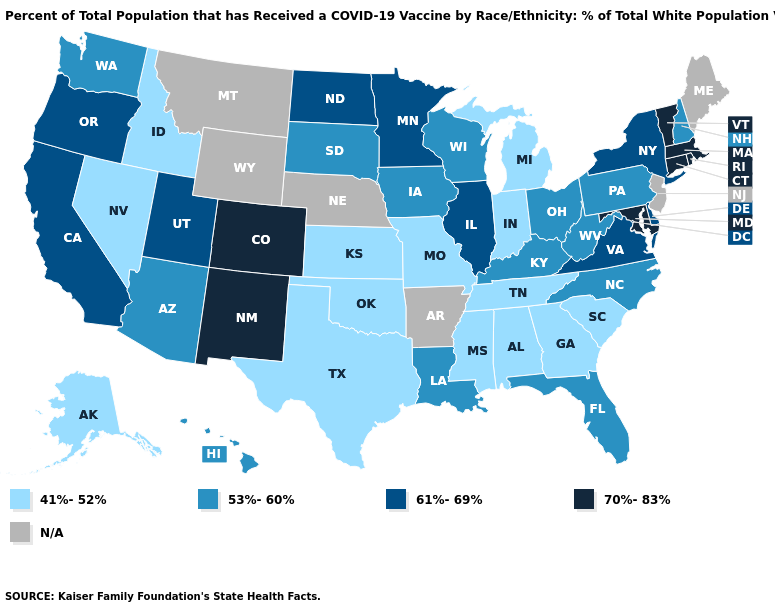Among the states that border South Dakota , does Iowa have the lowest value?
Short answer required. Yes. Does the first symbol in the legend represent the smallest category?
Short answer required. Yes. Does the map have missing data?
Concise answer only. Yes. Among the states that border Montana , which have the lowest value?
Answer briefly. Idaho. What is the lowest value in the USA?
Quick response, please. 41%-52%. What is the lowest value in the MidWest?
Be succinct. 41%-52%. What is the value of Minnesota?
Concise answer only. 61%-69%. What is the value of Nebraska?
Write a very short answer. N/A. Among the states that border Vermont , does New York have the highest value?
Short answer required. No. Does the first symbol in the legend represent the smallest category?
Concise answer only. Yes. Among the states that border Kentucky , does West Virginia have the lowest value?
Answer briefly. No. What is the value of New Mexico?
Be succinct. 70%-83%. Does Utah have the highest value in the West?
Short answer required. No. 